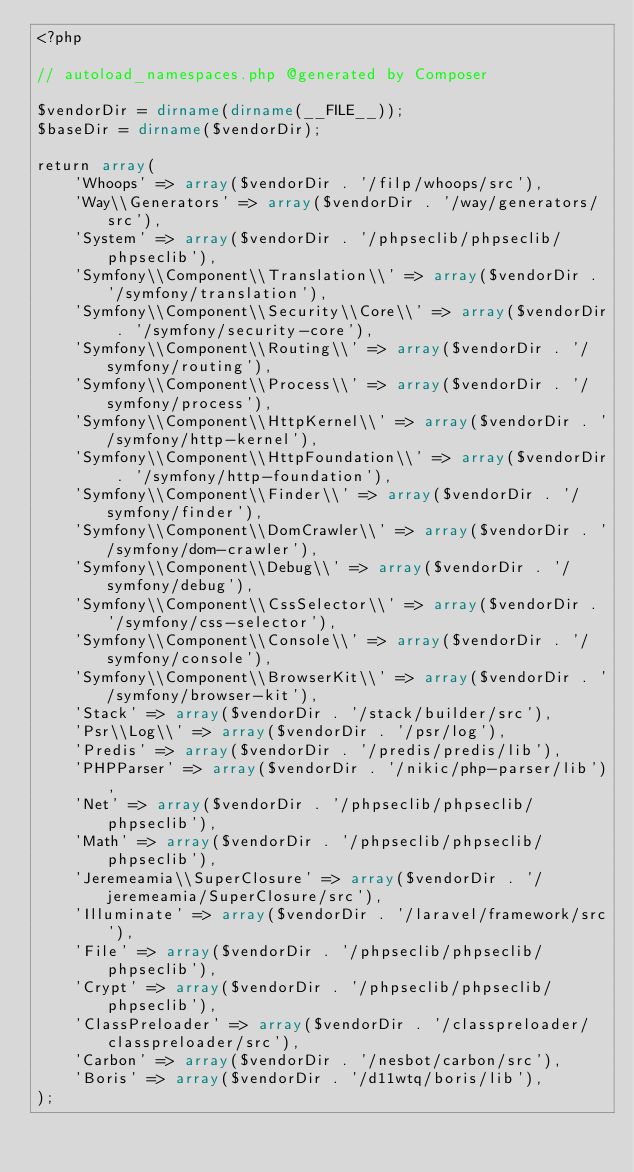Convert code to text. <code><loc_0><loc_0><loc_500><loc_500><_PHP_><?php

// autoload_namespaces.php @generated by Composer

$vendorDir = dirname(dirname(__FILE__));
$baseDir = dirname($vendorDir);

return array(
    'Whoops' => array($vendorDir . '/filp/whoops/src'),
    'Way\\Generators' => array($vendorDir . '/way/generators/src'),
    'System' => array($vendorDir . '/phpseclib/phpseclib/phpseclib'),
    'Symfony\\Component\\Translation\\' => array($vendorDir . '/symfony/translation'),
    'Symfony\\Component\\Security\\Core\\' => array($vendorDir . '/symfony/security-core'),
    'Symfony\\Component\\Routing\\' => array($vendorDir . '/symfony/routing'),
    'Symfony\\Component\\Process\\' => array($vendorDir . '/symfony/process'),
    'Symfony\\Component\\HttpKernel\\' => array($vendorDir . '/symfony/http-kernel'),
    'Symfony\\Component\\HttpFoundation\\' => array($vendorDir . '/symfony/http-foundation'),
    'Symfony\\Component\\Finder\\' => array($vendorDir . '/symfony/finder'),
    'Symfony\\Component\\DomCrawler\\' => array($vendorDir . '/symfony/dom-crawler'),
    'Symfony\\Component\\Debug\\' => array($vendorDir . '/symfony/debug'),
    'Symfony\\Component\\CssSelector\\' => array($vendorDir . '/symfony/css-selector'),
    'Symfony\\Component\\Console\\' => array($vendorDir . '/symfony/console'),
    'Symfony\\Component\\BrowserKit\\' => array($vendorDir . '/symfony/browser-kit'),
    'Stack' => array($vendorDir . '/stack/builder/src'),
    'Psr\\Log\\' => array($vendorDir . '/psr/log'),
    'Predis' => array($vendorDir . '/predis/predis/lib'),
    'PHPParser' => array($vendorDir . '/nikic/php-parser/lib'),
    'Net' => array($vendorDir . '/phpseclib/phpseclib/phpseclib'),
    'Math' => array($vendorDir . '/phpseclib/phpseclib/phpseclib'),
    'Jeremeamia\\SuperClosure' => array($vendorDir . '/jeremeamia/SuperClosure/src'),
    'Illuminate' => array($vendorDir . '/laravel/framework/src'),
    'File' => array($vendorDir . '/phpseclib/phpseclib/phpseclib'),
    'Crypt' => array($vendorDir . '/phpseclib/phpseclib/phpseclib'),
    'ClassPreloader' => array($vendorDir . '/classpreloader/classpreloader/src'),
    'Carbon' => array($vendorDir . '/nesbot/carbon/src'),
    'Boris' => array($vendorDir . '/d11wtq/boris/lib'),
);
</code> 